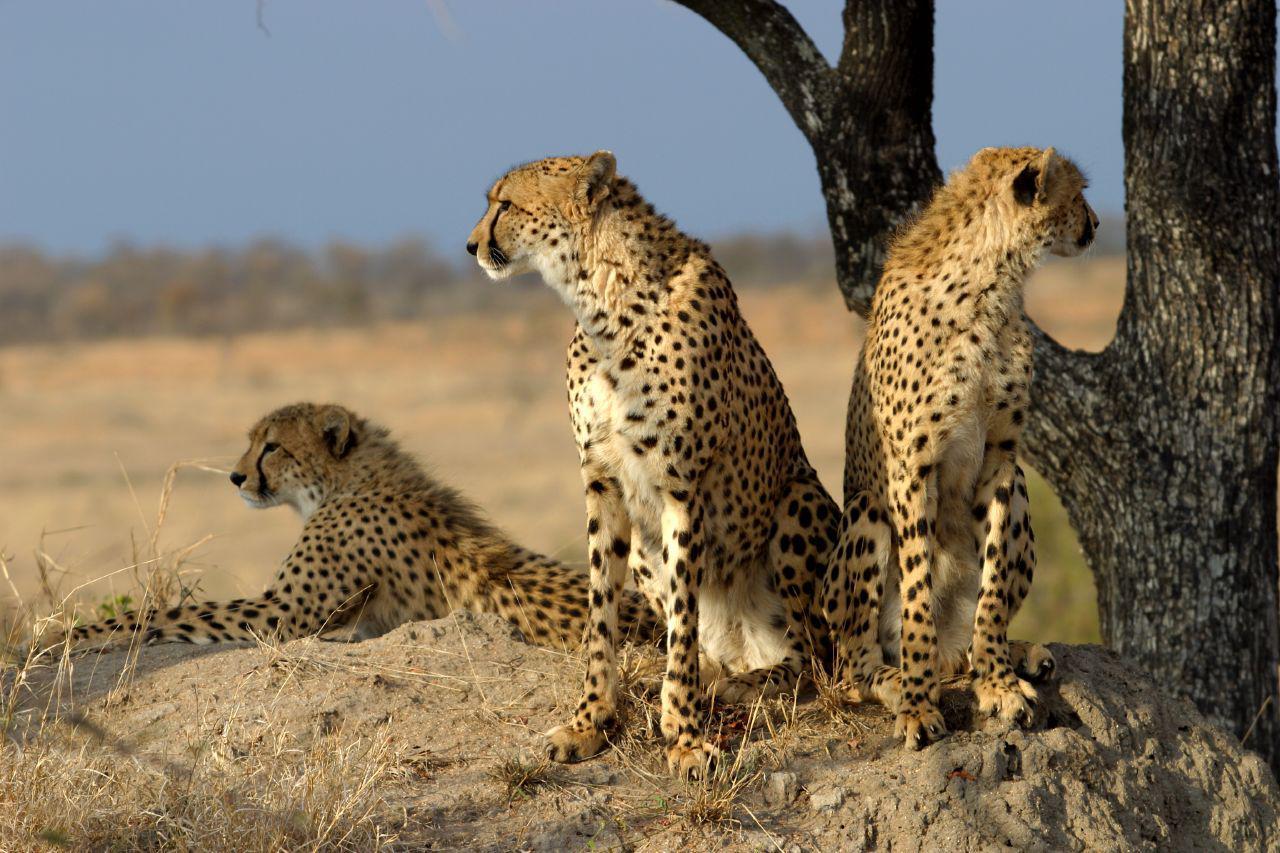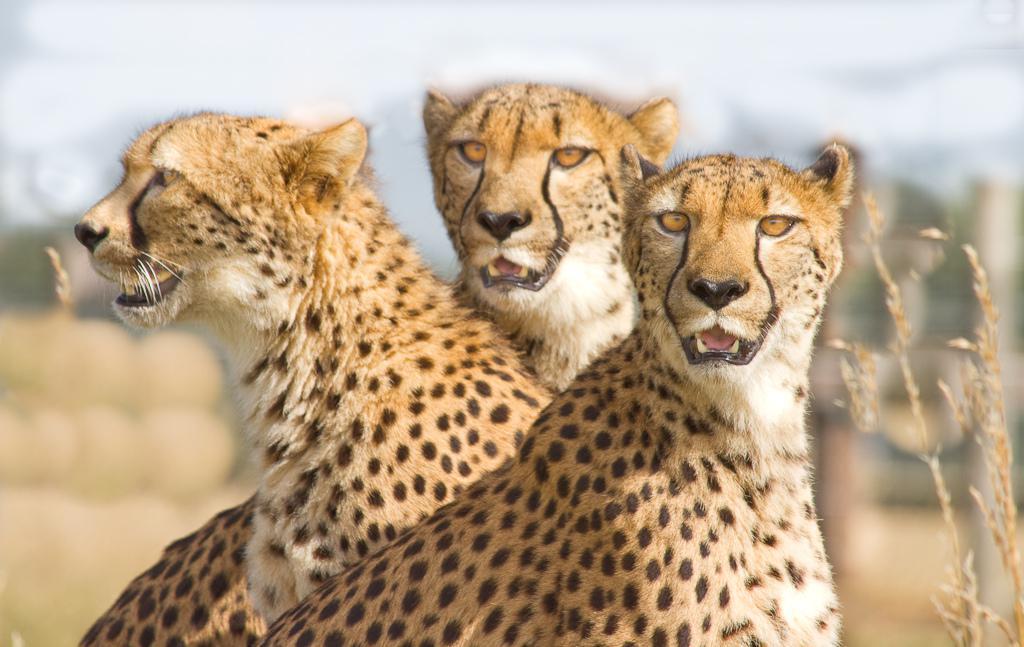The first image is the image on the left, the second image is the image on the right. Given the left and right images, does the statement "Three cheetahs rest near a tree." hold true? Answer yes or no. Yes. The first image is the image on the left, the second image is the image on the right. Examine the images to the left and right. Is the description "Each image contains three spotted cats, and at least some of the cats are not reclining." accurate? Answer yes or no. Yes. 